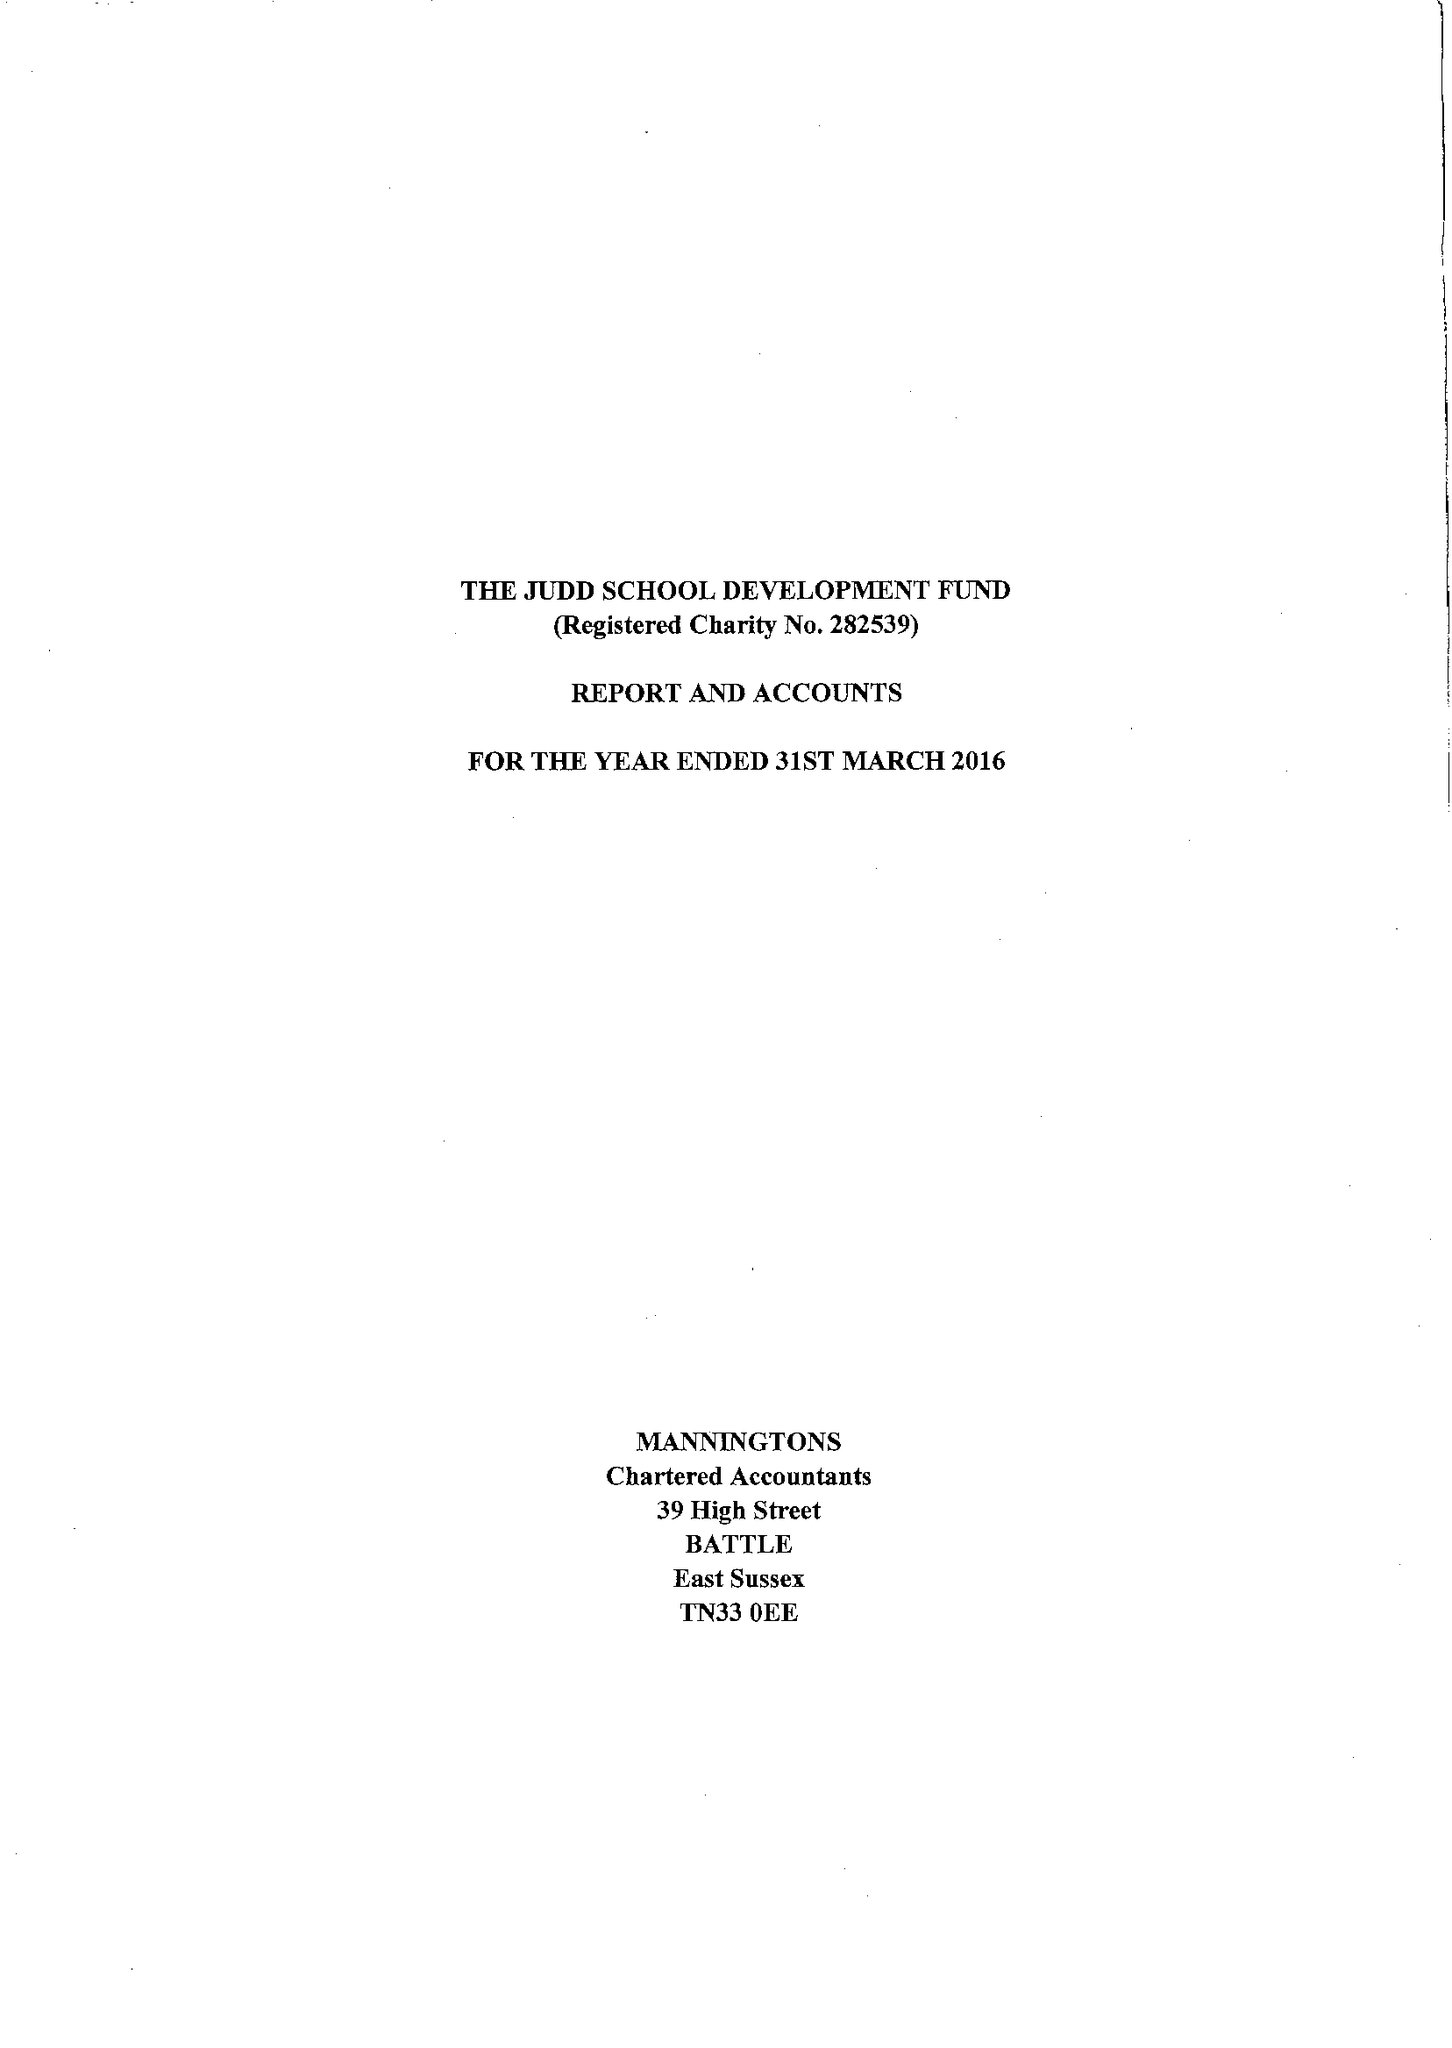What is the value for the address__postcode?
Answer the question using a single word or phrase. EC4R 2SP 